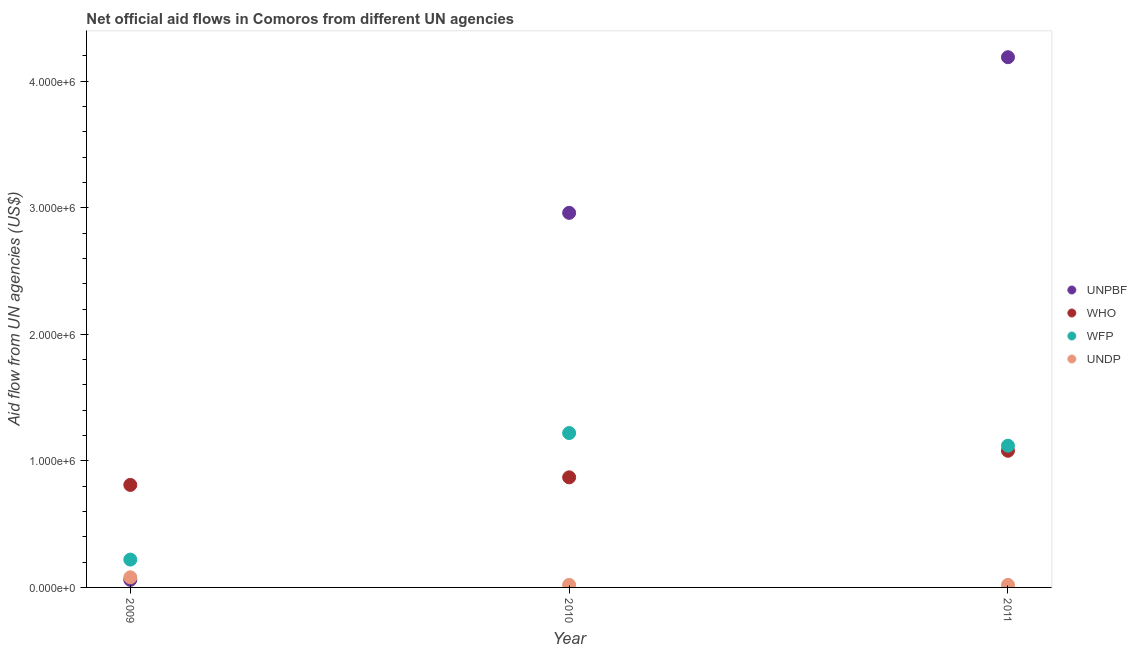What is the amount of aid given by who in 2010?
Offer a very short reply. 8.70e+05. Across all years, what is the maximum amount of aid given by undp?
Keep it short and to the point. 8.00e+04. Across all years, what is the minimum amount of aid given by wfp?
Keep it short and to the point. 2.20e+05. What is the total amount of aid given by who in the graph?
Ensure brevity in your answer.  2.76e+06. What is the difference between the amount of aid given by unpbf in 2010 and that in 2011?
Provide a short and direct response. -1.23e+06. What is the difference between the amount of aid given by undp in 2011 and the amount of aid given by wfp in 2009?
Offer a terse response. -2.00e+05. What is the average amount of aid given by unpbf per year?
Your response must be concise. 2.40e+06. In the year 2011, what is the difference between the amount of aid given by who and amount of aid given by unpbf?
Ensure brevity in your answer.  -3.11e+06. In how many years, is the amount of aid given by unpbf greater than 1600000 US$?
Provide a short and direct response. 2. What is the ratio of the amount of aid given by undp in 2010 to that in 2011?
Keep it short and to the point. 1. What is the difference between the highest and the second highest amount of aid given by unpbf?
Keep it short and to the point. 1.23e+06. What is the difference between the highest and the lowest amount of aid given by undp?
Provide a succinct answer. 6.00e+04. Is the amount of aid given by wfp strictly less than the amount of aid given by undp over the years?
Your answer should be compact. No. Does the graph contain any zero values?
Your answer should be very brief. No. Does the graph contain grids?
Your response must be concise. No. What is the title of the graph?
Your response must be concise. Net official aid flows in Comoros from different UN agencies. What is the label or title of the Y-axis?
Your answer should be compact. Aid flow from UN agencies (US$). What is the Aid flow from UN agencies (US$) in WHO in 2009?
Your answer should be very brief. 8.10e+05. What is the Aid flow from UN agencies (US$) of UNDP in 2009?
Your response must be concise. 8.00e+04. What is the Aid flow from UN agencies (US$) in UNPBF in 2010?
Offer a very short reply. 2.96e+06. What is the Aid flow from UN agencies (US$) of WHO in 2010?
Your answer should be compact. 8.70e+05. What is the Aid flow from UN agencies (US$) in WFP in 2010?
Your answer should be compact. 1.22e+06. What is the Aid flow from UN agencies (US$) of UNPBF in 2011?
Make the answer very short. 4.19e+06. What is the Aid flow from UN agencies (US$) in WHO in 2011?
Ensure brevity in your answer.  1.08e+06. What is the Aid flow from UN agencies (US$) of WFP in 2011?
Provide a short and direct response. 1.12e+06. What is the Aid flow from UN agencies (US$) of UNDP in 2011?
Offer a terse response. 2.00e+04. Across all years, what is the maximum Aid flow from UN agencies (US$) of UNPBF?
Make the answer very short. 4.19e+06. Across all years, what is the maximum Aid flow from UN agencies (US$) of WHO?
Ensure brevity in your answer.  1.08e+06. Across all years, what is the maximum Aid flow from UN agencies (US$) of WFP?
Provide a succinct answer. 1.22e+06. Across all years, what is the minimum Aid flow from UN agencies (US$) in UNPBF?
Offer a very short reply. 6.00e+04. Across all years, what is the minimum Aid flow from UN agencies (US$) of WHO?
Offer a very short reply. 8.10e+05. Across all years, what is the minimum Aid flow from UN agencies (US$) in WFP?
Give a very brief answer. 2.20e+05. What is the total Aid flow from UN agencies (US$) of UNPBF in the graph?
Your response must be concise. 7.21e+06. What is the total Aid flow from UN agencies (US$) of WHO in the graph?
Your response must be concise. 2.76e+06. What is the total Aid flow from UN agencies (US$) in WFP in the graph?
Make the answer very short. 2.56e+06. What is the difference between the Aid flow from UN agencies (US$) of UNPBF in 2009 and that in 2010?
Make the answer very short. -2.90e+06. What is the difference between the Aid flow from UN agencies (US$) of WHO in 2009 and that in 2010?
Give a very brief answer. -6.00e+04. What is the difference between the Aid flow from UN agencies (US$) of UNPBF in 2009 and that in 2011?
Make the answer very short. -4.13e+06. What is the difference between the Aid flow from UN agencies (US$) in WHO in 2009 and that in 2011?
Give a very brief answer. -2.70e+05. What is the difference between the Aid flow from UN agencies (US$) of WFP in 2009 and that in 2011?
Provide a short and direct response. -9.00e+05. What is the difference between the Aid flow from UN agencies (US$) in UNDP in 2009 and that in 2011?
Ensure brevity in your answer.  6.00e+04. What is the difference between the Aid flow from UN agencies (US$) in UNPBF in 2010 and that in 2011?
Offer a very short reply. -1.23e+06. What is the difference between the Aid flow from UN agencies (US$) of WHO in 2010 and that in 2011?
Keep it short and to the point. -2.10e+05. What is the difference between the Aid flow from UN agencies (US$) of WFP in 2010 and that in 2011?
Give a very brief answer. 1.00e+05. What is the difference between the Aid flow from UN agencies (US$) of UNPBF in 2009 and the Aid flow from UN agencies (US$) of WHO in 2010?
Your answer should be very brief. -8.10e+05. What is the difference between the Aid flow from UN agencies (US$) in UNPBF in 2009 and the Aid flow from UN agencies (US$) in WFP in 2010?
Offer a very short reply. -1.16e+06. What is the difference between the Aid flow from UN agencies (US$) in UNPBF in 2009 and the Aid flow from UN agencies (US$) in UNDP in 2010?
Offer a terse response. 4.00e+04. What is the difference between the Aid flow from UN agencies (US$) of WHO in 2009 and the Aid flow from UN agencies (US$) of WFP in 2010?
Provide a succinct answer. -4.10e+05. What is the difference between the Aid flow from UN agencies (US$) in WHO in 2009 and the Aid flow from UN agencies (US$) in UNDP in 2010?
Offer a terse response. 7.90e+05. What is the difference between the Aid flow from UN agencies (US$) in UNPBF in 2009 and the Aid flow from UN agencies (US$) in WHO in 2011?
Your response must be concise. -1.02e+06. What is the difference between the Aid flow from UN agencies (US$) of UNPBF in 2009 and the Aid flow from UN agencies (US$) of WFP in 2011?
Give a very brief answer. -1.06e+06. What is the difference between the Aid flow from UN agencies (US$) of WHO in 2009 and the Aid flow from UN agencies (US$) of WFP in 2011?
Make the answer very short. -3.10e+05. What is the difference between the Aid flow from UN agencies (US$) of WHO in 2009 and the Aid flow from UN agencies (US$) of UNDP in 2011?
Provide a succinct answer. 7.90e+05. What is the difference between the Aid flow from UN agencies (US$) in UNPBF in 2010 and the Aid flow from UN agencies (US$) in WHO in 2011?
Ensure brevity in your answer.  1.88e+06. What is the difference between the Aid flow from UN agencies (US$) in UNPBF in 2010 and the Aid flow from UN agencies (US$) in WFP in 2011?
Make the answer very short. 1.84e+06. What is the difference between the Aid flow from UN agencies (US$) in UNPBF in 2010 and the Aid flow from UN agencies (US$) in UNDP in 2011?
Provide a short and direct response. 2.94e+06. What is the difference between the Aid flow from UN agencies (US$) of WHO in 2010 and the Aid flow from UN agencies (US$) of UNDP in 2011?
Ensure brevity in your answer.  8.50e+05. What is the difference between the Aid flow from UN agencies (US$) in WFP in 2010 and the Aid flow from UN agencies (US$) in UNDP in 2011?
Offer a very short reply. 1.20e+06. What is the average Aid flow from UN agencies (US$) of UNPBF per year?
Provide a succinct answer. 2.40e+06. What is the average Aid flow from UN agencies (US$) in WHO per year?
Make the answer very short. 9.20e+05. What is the average Aid flow from UN agencies (US$) in WFP per year?
Provide a succinct answer. 8.53e+05. In the year 2009, what is the difference between the Aid flow from UN agencies (US$) of UNPBF and Aid flow from UN agencies (US$) of WHO?
Give a very brief answer. -7.50e+05. In the year 2009, what is the difference between the Aid flow from UN agencies (US$) of WHO and Aid flow from UN agencies (US$) of WFP?
Keep it short and to the point. 5.90e+05. In the year 2009, what is the difference between the Aid flow from UN agencies (US$) of WHO and Aid flow from UN agencies (US$) of UNDP?
Give a very brief answer. 7.30e+05. In the year 2009, what is the difference between the Aid flow from UN agencies (US$) in WFP and Aid flow from UN agencies (US$) in UNDP?
Provide a succinct answer. 1.40e+05. In the year 2010, what is the difference between the Aid flow from UN agencies (US$) of UNPBF and Aid flow from UN agencies (US$) of WHO?
Your answer should be compact. 2.09e+06. In the year 2010, what is the difference between the Aid flow from UN agencies (US$) in UNPBF and Aid flow from UN agencies (US$) in WFP?
Provide a succinct answer. 1.74e+06. In the year 2010, what is the difference between the Aid flow from UN agencies (US$) of UNPBF and Aid flow from UN agencies (US$) of UNDP?
Keep it short and to the point. 2.94e+06. In the year 2010, what is the difference between the Aid flow from UN agencies (US$) of WHO and Aid flow from UN agencies (US$) of WFP?
Provide a short and direct response. -3.50e+05. In the year 2010, what is the difference between the Aid flow from UN agencies (US$) in WHO and Aid flow from UN agencies (US$) in UNDP?
Keep it short and to the point. 8.50e+05. In the year 2010, what is the difference between the Aid flow from UN agencies (US$) of WFP and Aid flow from UN agencies (US$) of UNDP?
Give a very brief answer. 1.20e+06. In the year 2011, what is the difference between the Aid flow from UN agencies (US$) of UNPBF and Aid flow from UN agencies (US$) of WHO?
Offer a terse response. 3.11e+06. In the year 2011, what is the difference between the Aid flow from UN agencies (US$) in UNPBF and Aid flow from UN agencies (US$) in WFP?
Your answer should be very brief. 3.07e+06. In the year 2011, what is the difference between the Aid flow from UN agencies (US$) of UNPBF and Aid flow from UN agencies (US$) of UNDP?
Provide a short and direct response. 4.17e+06. In the year 2011, what is the difference between the Aid flow from UN agencies (US$) of WHO and Aid flow from UN agencies (US$) of WFP?
Provide a short and direct response. -4.00e+04. In the year 2011, what is the difference between the Aid flow from UN agencies (US$) of WHO and Aid flow from UN agencies (US$) of UNDP?
Your response must be concise. 1.06e+06. In the year 2011, what is the difference between the Aid flow from UN agencies (US$) of WFP and Aid flow from UN agencies (US$) of UNDP?
Ensure brevity in your answer.  1.10e+06. What is the ratio of the Aid flow from UN agencies (US$) of UNPBF in 2009 to that in 2010?
Provide a short and direct response. 0.02. What is the ratio of the Aid flow from UN agencies (US$) in WHO in 2009 to that in 2010?
Keep it short and to the point. 0.93. What is the ratio of the Aid flow from UN agencies (US$) in WFP in 2009 to that in 2010?
Ensure brevity in your answer.  0.18. What is the ratio of the Aid flow from UN agencies (US$) in UNPBF in 2009 to that in 2011?
Your answer should be compact. 0.01. What is the ratio of the Aid flow from UN agencies (US$) of WFP in 2009 to that in 2011?
Your response must be concise. 0.2. What is the ratio of the Aid flow from UN agencies (US$) in UNDP in 2009 to that in 2011?
Your answer should be compact. 4. What is the ratio of the Aid flow from UN agencies (US$) of UNPBF in 2010 to that in 2011?
Your answer should be very brief. 0.71. What is the ratio of the Aid flow from UN agencies (US$) of WHO in 2010 to that in 2011?
Offer a terse response. 0.81. What is the ratio of the Aid flow from UN agencies (US$) of WFP in 2010 to that in 2011?
Offer a very short reply. 1.09. What is the ratio of the Aid flow from UN agencies (US$) of UNDP in 2010 to that in 2011?
Provide a short and direct response. 1. What is the difference between the highest and the second highest Aid flow from UN agencies (US$) of UNPBF?
Keep it short and to the point. 1.23e+06. What is the difference between the highest and the second highest Aid flow from UN agencies (US$) in WHO?
Your answer should be very brief. 2.10e+05. What is the difference between the highest and the second highest Aid flow from UN agencies (US$) in UNDP?
Offer a terse response. 6.00e+04. What is the difference between the highest and the lowest Aid flow from UN agencies (US$) of UNPBF?
Your answer should be very brief. 4.13e+06. What is the difference between the highest and the lowest Aid flow from UN agencies (US$) of WFP?
Give a very brief answer. 1.00e+06. What is the difference between the highest and the lowest Aid flow from UN agencies (US$) of UNDP?
Provide a short and direct response. 6.00e+04. 